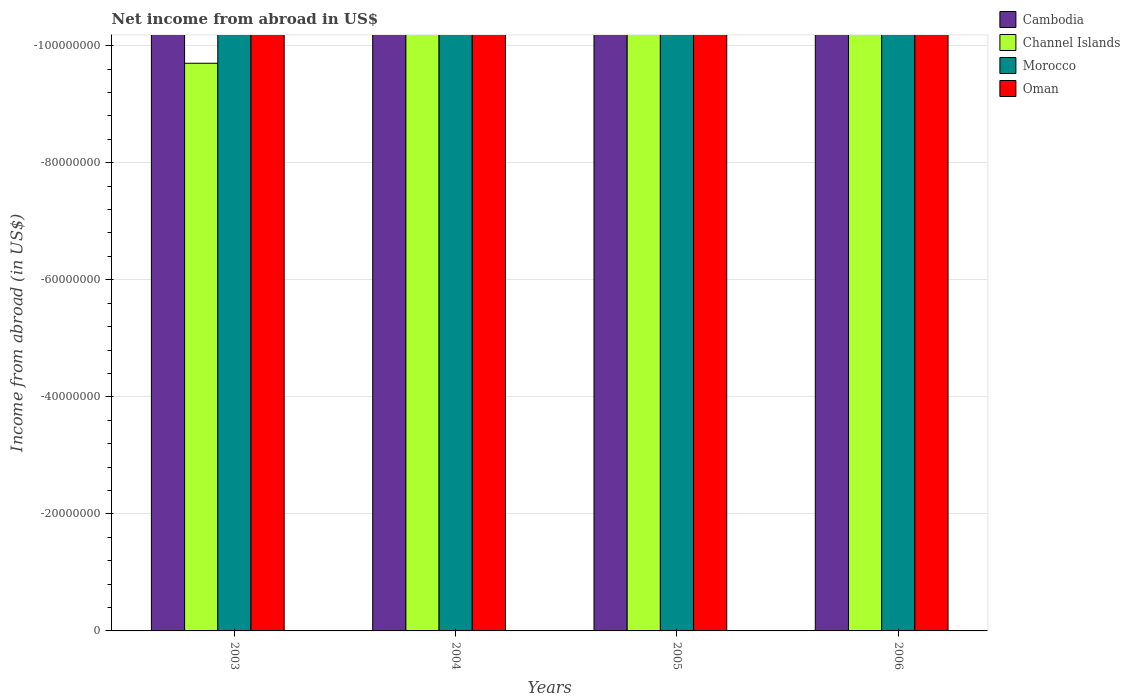How many different coloured bars are there?
Make the answer very short. 0. How many bars are there on the 3rd tick from the left?
Your answer should be very brief. 0. What is the label of the 4th group of bars from the left?
Give a very brief answer. 2006. Across all years, what is the minimum net income from abroad in Channel Islands?
Keep it short and to the point. 0. What is the difference between the net income from abroad in Channel Islands in 2005 and the net income from abroad in Morocco in 2003?
Provide a short and direct response. 0. In how many years, is the net income from abroad in Channel Islands greater than -12000000 US$?
Offer a very short reply. 0. How many bars are there?
Your response must be concise. 0. Are all the bars in the graph horizontal?
Make the answer very short. No. How many years are there in the graph?
Offer a terse response. 4. Does the graph contain any zero values?
Keep it short and to the point. Yes. Does the graph contain grids?
Provide a succinct answer. Yes. What is the title of the graph?
Offer a very short reply. Net income from abroad in US$. Does "Switzerland" appear as one of the legend labels in the graph?
Offer a very short reply. No. What is the label or title of the X-axis?
Provide a succinct answer. Years. What is the label or title of the Y-axis?
Your answer should be very brief. Income from abroad (in US$). What is the Income from abroad (in US$) in Cambodia in 2003?
Offer a very short reply. 0. What is the Income from abroad (in US$) in Channel Islands in 2003?
Keep it short and to the point. 0. What is the Income from abroad (in US$) in Morocco in 2003?
Offer a terse response. 0. What is the Income from abroad (in US$) in Oman in 2003?
Offer a very short reply. 0. What is the Income from abroad (in US$) in Cambodia in 2004?
Your answer should be very brief. 0. What is the Income from abroad (in US$) of Morocco in 2004?
Give a very brief answer. 0. What is the Income from abroad (in US$) of Oman in 2004?
Offer a terse response. 0. What is the Income from abroad (in US$) in Morocco in 2005?
Your response must be concise. 0. What is the Income from abroad (in US$) in Morocco in 2006?
Your answer should be very brief. 0. What is the Income from abroad (in US$) in Oman in 2006?
Offer a terse response. 0. What is the total Income from abroad (in US$) in Channel Islands in the graph?
Give a very brief answer. 0. What is the total Income from abroad (in US$) of Morocco in the graph?
Provide a succinct answer. 0. What is the total Income from abroad (in US$) of Oman in the graph?
Your response must be concise. 0. What is the average Income from abroad (in US$) in Channel Islands per year?
Give a very brief answer. 0. What is the average Income from abroad (in US$) of Morocco per year?
Your answer should be very brief. 0. 